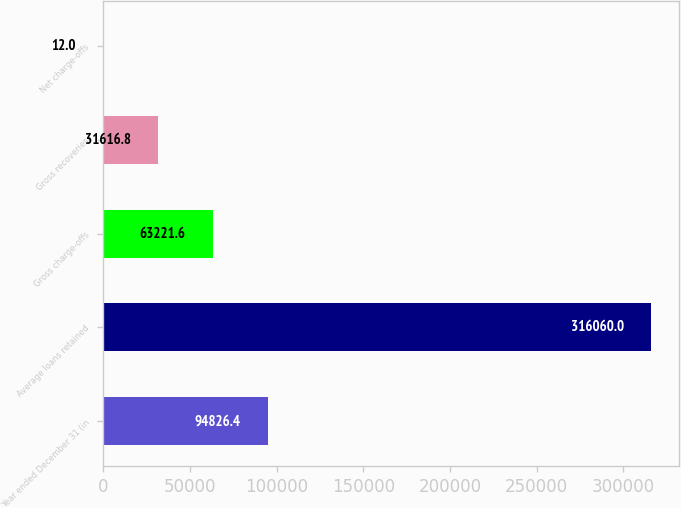<chart> <loc_0><loc_0><loc_500><loc_500><bar_chart><fcel>Year ended December 31 (in<fcel>Average loans retained<fcel>Gross charge-offs<fcel>Gross recoveries<fcel>Net charge-offs<nl><fcel>94826.4<fcel>316060<fcel>63221.6<fcel>31616.8<fcel>12<nl></chart> 